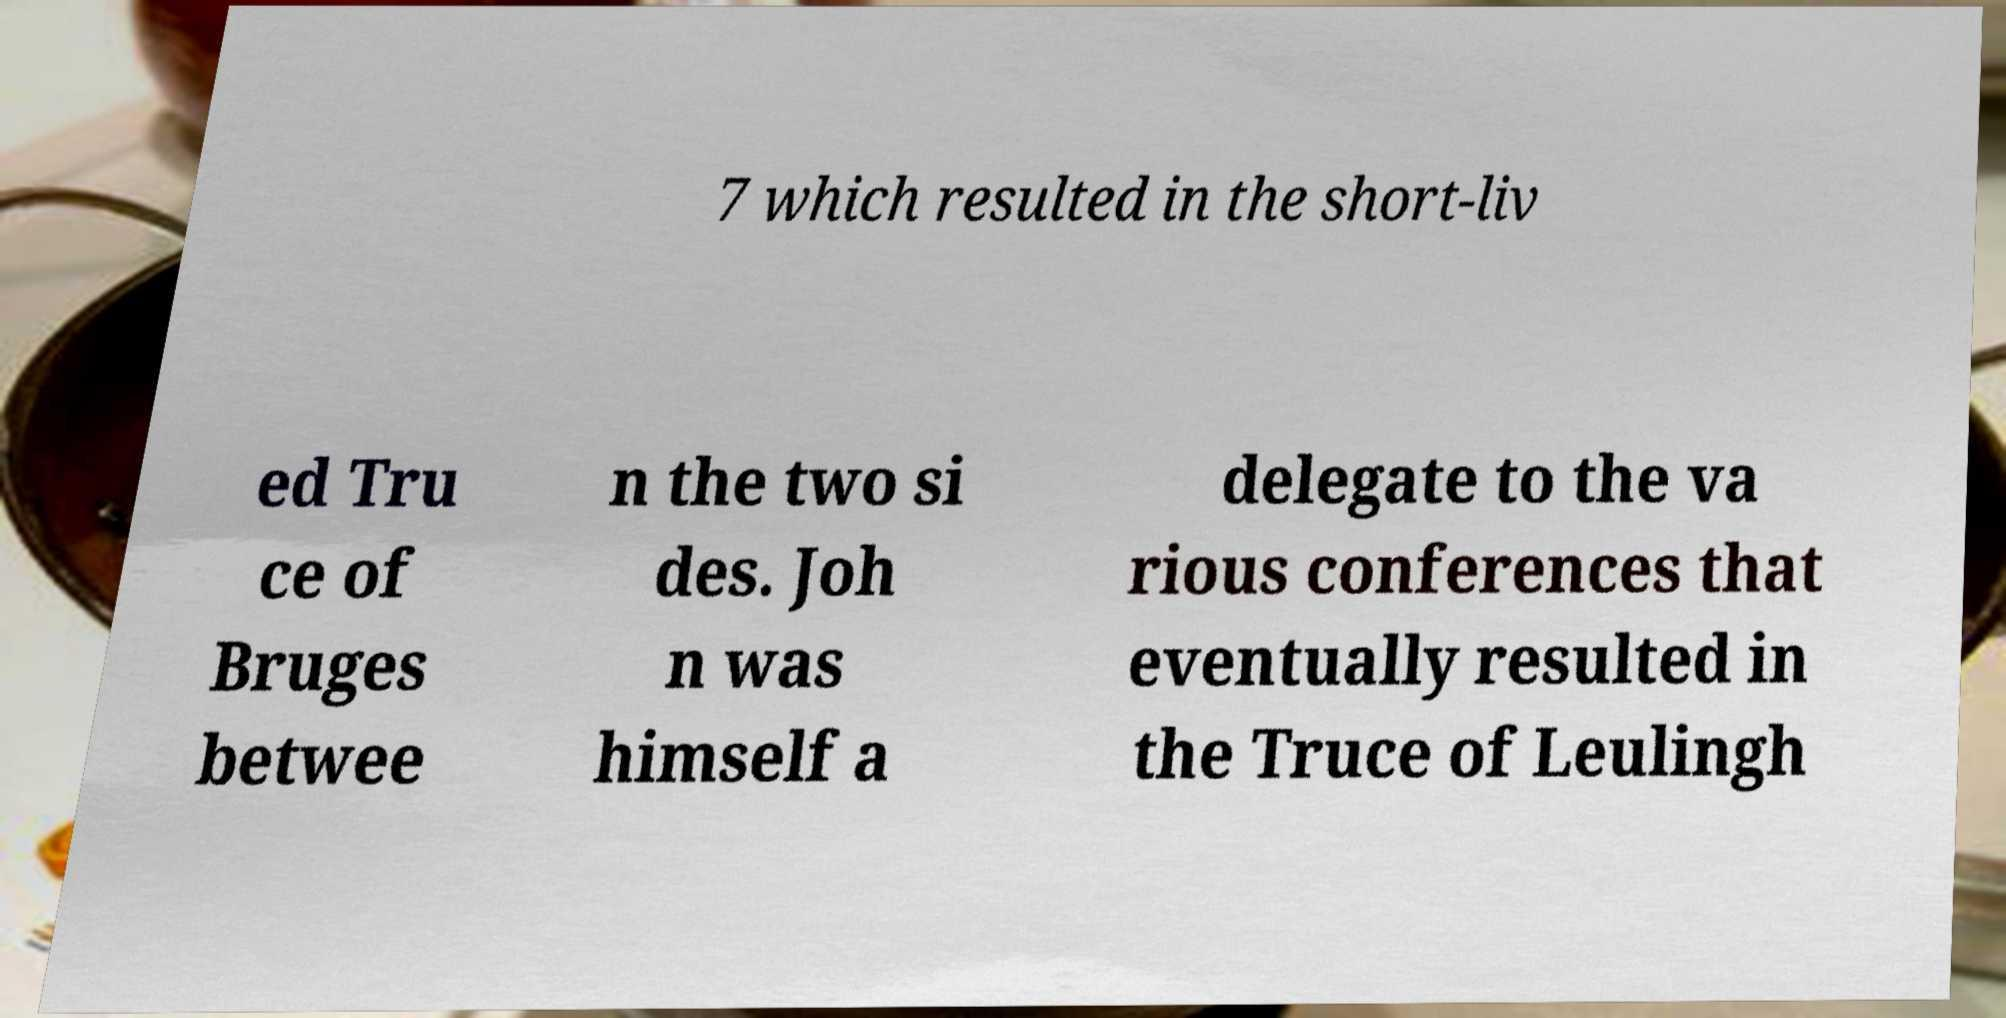Could you extract and type out the text from this image? 7 which resulted in the short-liv ed Tru ce of Bruges betwee n the two si des. Joh n was himself a delegate to the va rious conferences that eventually resulted in the Truce of Leulingh 